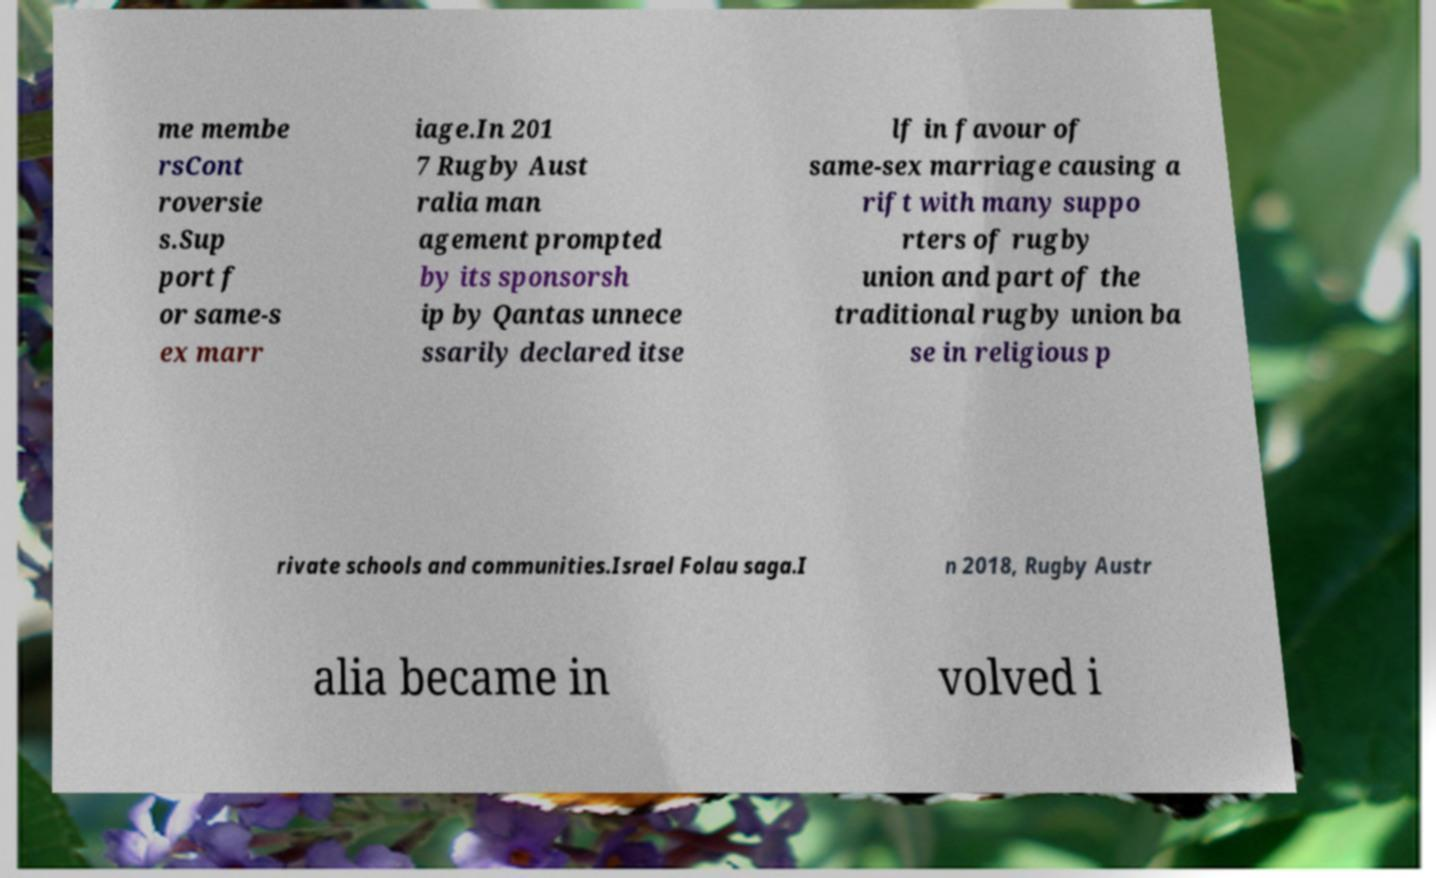Please identify and transcribe the text found in this image. me membe rsCont roversie s.Sup port f or same-s ex marr iage.In 201 7 Rugby Aust ralia man agement prompted by its sponsorsh ip by Qantas unnece ssarily declared itse lf in favour of same-sex marriage causing a rift with many suppo rters of rugby union and part of the traditional rugby union ba se in religious p rivate schools and communities.Israel Folau saga.I n 2018, Rugby Austr alia became in volved i 